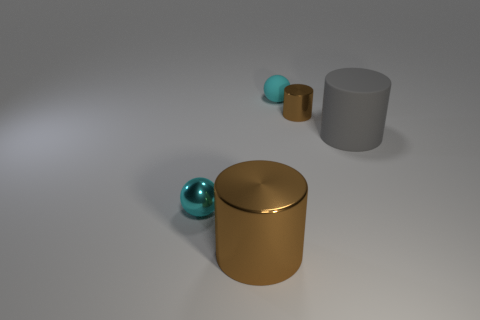How many cylinders are the same color as the small metallic sphere?
Give a very brief answer. 0. There is a metal thing that is in front of the metallic sphere; how big is it?
Provide a short and direct response. Large. What is the shape of the brown metallic thing that is behind the small ball in front of the brown cylinder behind the cyan metal object?
Ensure brevity in your answer.  Cylinder. What is the shape of the shiny object that is in front of the gray thing and behind the large brown metallic object?
Keep it short and to the point. Sphere. Are there any gray cylinders of the same size as the cyan metallic thing?
Keep it short and to the point. No. There is a brown metallic thing that is on the left side of the matte ball; is its shape the same as the gray object?
Offer a very short reply. Yes. Do the big metal object and the small cyan rubber object have the same shape?
Make the answer very short. No. Is there a small metal object that has the same shape as the big brown metallic object?
Give a very brief answer. Yes. There is a small shiny thing that is on the left side of the large shiny object that is in front of the gray thing; what is its shape?
Make the answer very short. Sphere. There is a cylinder that is left of the tiny cyan rubber thing; what is its color?
Ensure brevity in your answer.  Brown. 